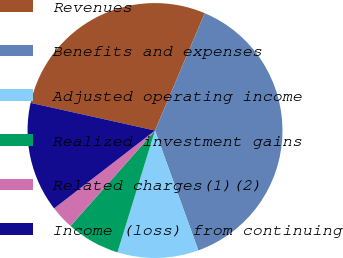Convert chart to OTSL. <chart><loc_0><loc_0><loc_500><loc_500><pie_chart><fcel>Revenues<fcel>Benefits and expenses<fcel>Adjusted operating income<fcel>Realized investment gains<fcel>Related charges(1)(2)<fcel>Income (loss) from continuing<nl><fcel>27.9%<fcel>38.1%<fcel>10.28%<fcel>6.77%<fcel>3.01%<fcel>13.95%<nl></chart> 